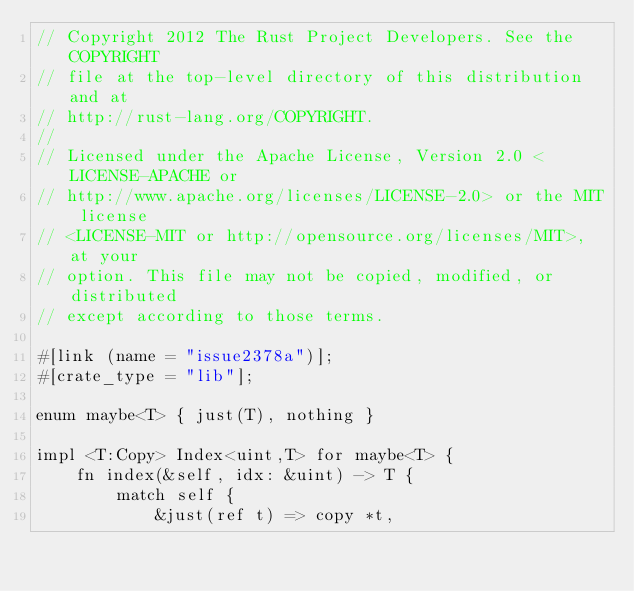<code> <loc_0><loc_0><loc_500><loc_500><_Rust_>// Copyright 2012 The Rust Project Developers. See the COPYRIGHT
// file at the top-level directory of this distribution and at
// http://rust-lang.org/COPYRIGHT.
//
// Licensed under the Apache License, Version 2.0 <LICENSE-APACHE or
// http://www.apache.org/licenses/LICENSE-2.0> or the MIT license
// <LICENSE-MIT or http://opensource.org/licenses/MIT>, at your
// option. This file may not be copied, modified, or distributed
// except according to those terms.

#[link (name = "issue2378a")];
#[crate_type = "lib"];

enum maybe<T> { just(T), nothing }

impl <T:Copy> Index<uint,T> for maybe<T> {
    fn index(&self, idx: &uint) -> T {
        match self {
            &just(ref t) => copy *t,</code> 